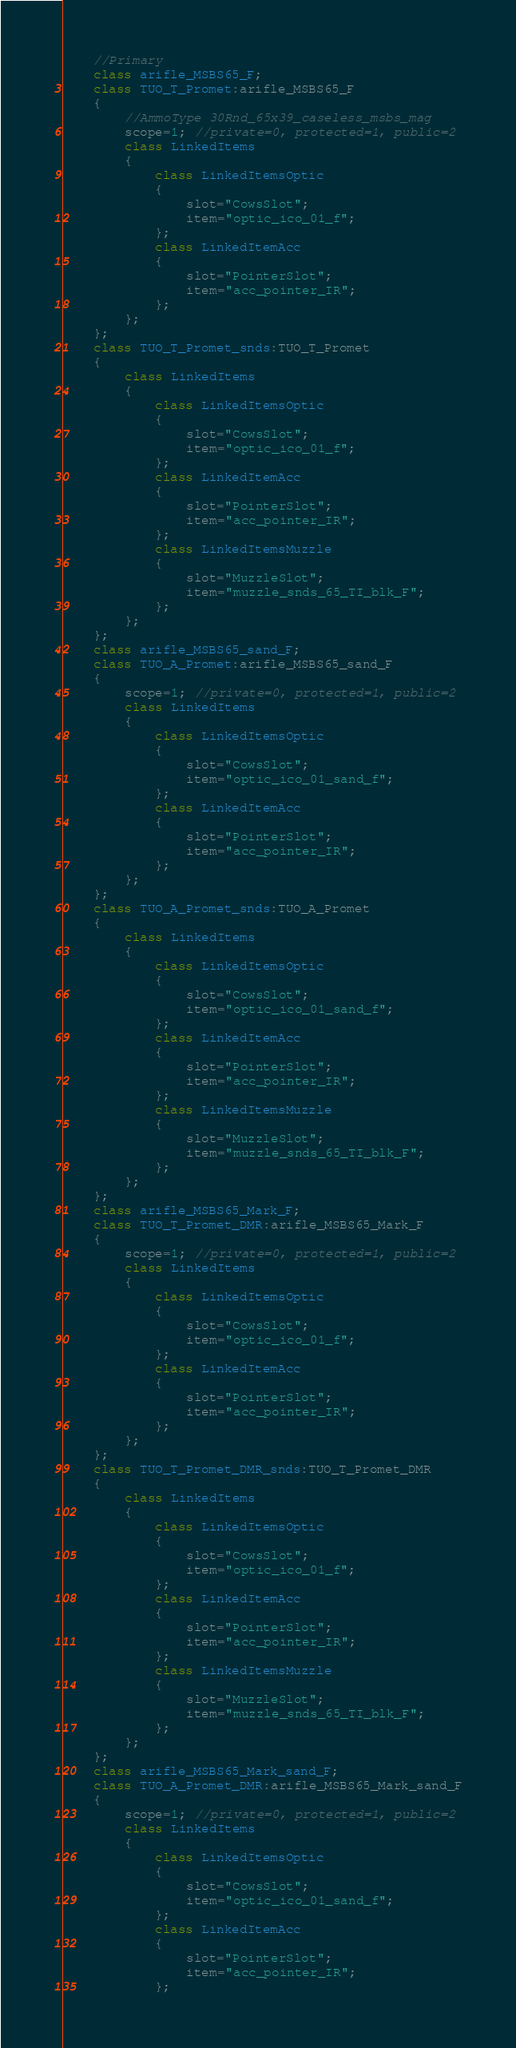Convert code to text. <code><loc_0><loc_0><loc_500><loc_500><_C++_>	//Primary
	class arifle_MSBS65_F;
	class TUO_T_Promet:arifle_MSBS65_F
	{
		//AmmoType 30Rnd_65x39_caseless_msbs_mag
		scope=1; //private=0, protected=1, public=2
		class LinkedItems
		{
			class LinkedItemsOptic
			{
				slot="CowsSlot";
				item="optic_ico_01_f";
			};
			class LinkedItemAcc
			{
				slot="PointerSlot";
				item="acc_pointer_IR";
			};
		};
	};
	class TUO_T_Promet_snds:TUO_T_Promet
	{
		class LinkedItems
		{
			class LinkedItemsOptic
			{
				slot="CowsSlot";
				item="optic_ico_01_f";
			};
			class LinkedItemAcc
			{
				slot="PointerSlot";
				item="acc_pointer_IR";
			};
			class LinkedItemsMuzzle
			{
				slot="MuzzleSlot";
				item="muzzle_snds_65_TI_blk_F";
			};
		};
	};
	class arifle_MSBS65_sand_F;
	class TUO_A_Promet:arifle_MSBS65_sand_F
	{
		scope=1; //private=0, protected=1, public=2
		class LinkedItems
		{
			class LinkedItemsOptic
			{
				slot="CowsSlot";
				item="optic_ico_01_sand_f";
			};
			class LinkedItemAcc
			{
				slot="PointerSlot";
				item="acc_pointer_IR";
			};
		};
	};
	class TUO_A_Promet_snds:TUO_A_Promet
	{
		class LinkedItems
		{
			class LinkedItemsOptic
			{
				slot="CowsSlot";
				item="optic_ico_01_sand_f";
			};
			class LinkedItemAcc
			{
				slot="PointerSlot";
				item="acc_pointer_IR";
			};
			class LinkedItemsMuzzle
			{
				slot="MuzzleSlot";
				item="muzzle_snds_65_TI_blk_F";
			};
		};
	};
	class arifle_MSBS65_Mark_F;
	class TUO_T_Promet_DMR:arifle_MSBS65_Mark_F
	{
		scope=1; //private=0, protected=1, public=2
		class LinkedItems
		{
			class LinkedItemsOptic
			{
				slot="CowsSlot";
				item="optic_ico_01_f";
			};
			class LinkedItemAcc
			{
				slot="PointerSlot";
				item="acc_pointer_IR";
			};
		};
	};
	class TUO_T_Promet_DMR_snds:TUO_T_Promet_DMR
	{
		class LinkedItems
		{
			class LinkedItemsOptic
			{
				slot="CowsSlot";
				item="optic_ico_01_f";
			};
			class LinkedItemAcc
			{
				slot="PointerSlot";
				item="acc_pointer_IR";
			};
			class LinkedItemsMuzzle
			{
				slot="MuzzleSlot";
				item="muzzle_snds_65_TI_blk_F";
			};
		};
	};
	class arifle_MSBS65_Mark_sand_F;
	class TUO_A_Promet_DMR:arifle_MSBS65_Mark_sand_F
	{
		scope=1; //private=0, protected=1, public=2
		class LinkedItems
		{
			class LinkedItemsOptic
			{
				slot="CowsSlot";
				item="optic_ico_01_sand_f";
			};
			class LinkedItemAcc
			{
				slot="PointerSlot";
				item="acc_pointer_IR";
			};</code> 